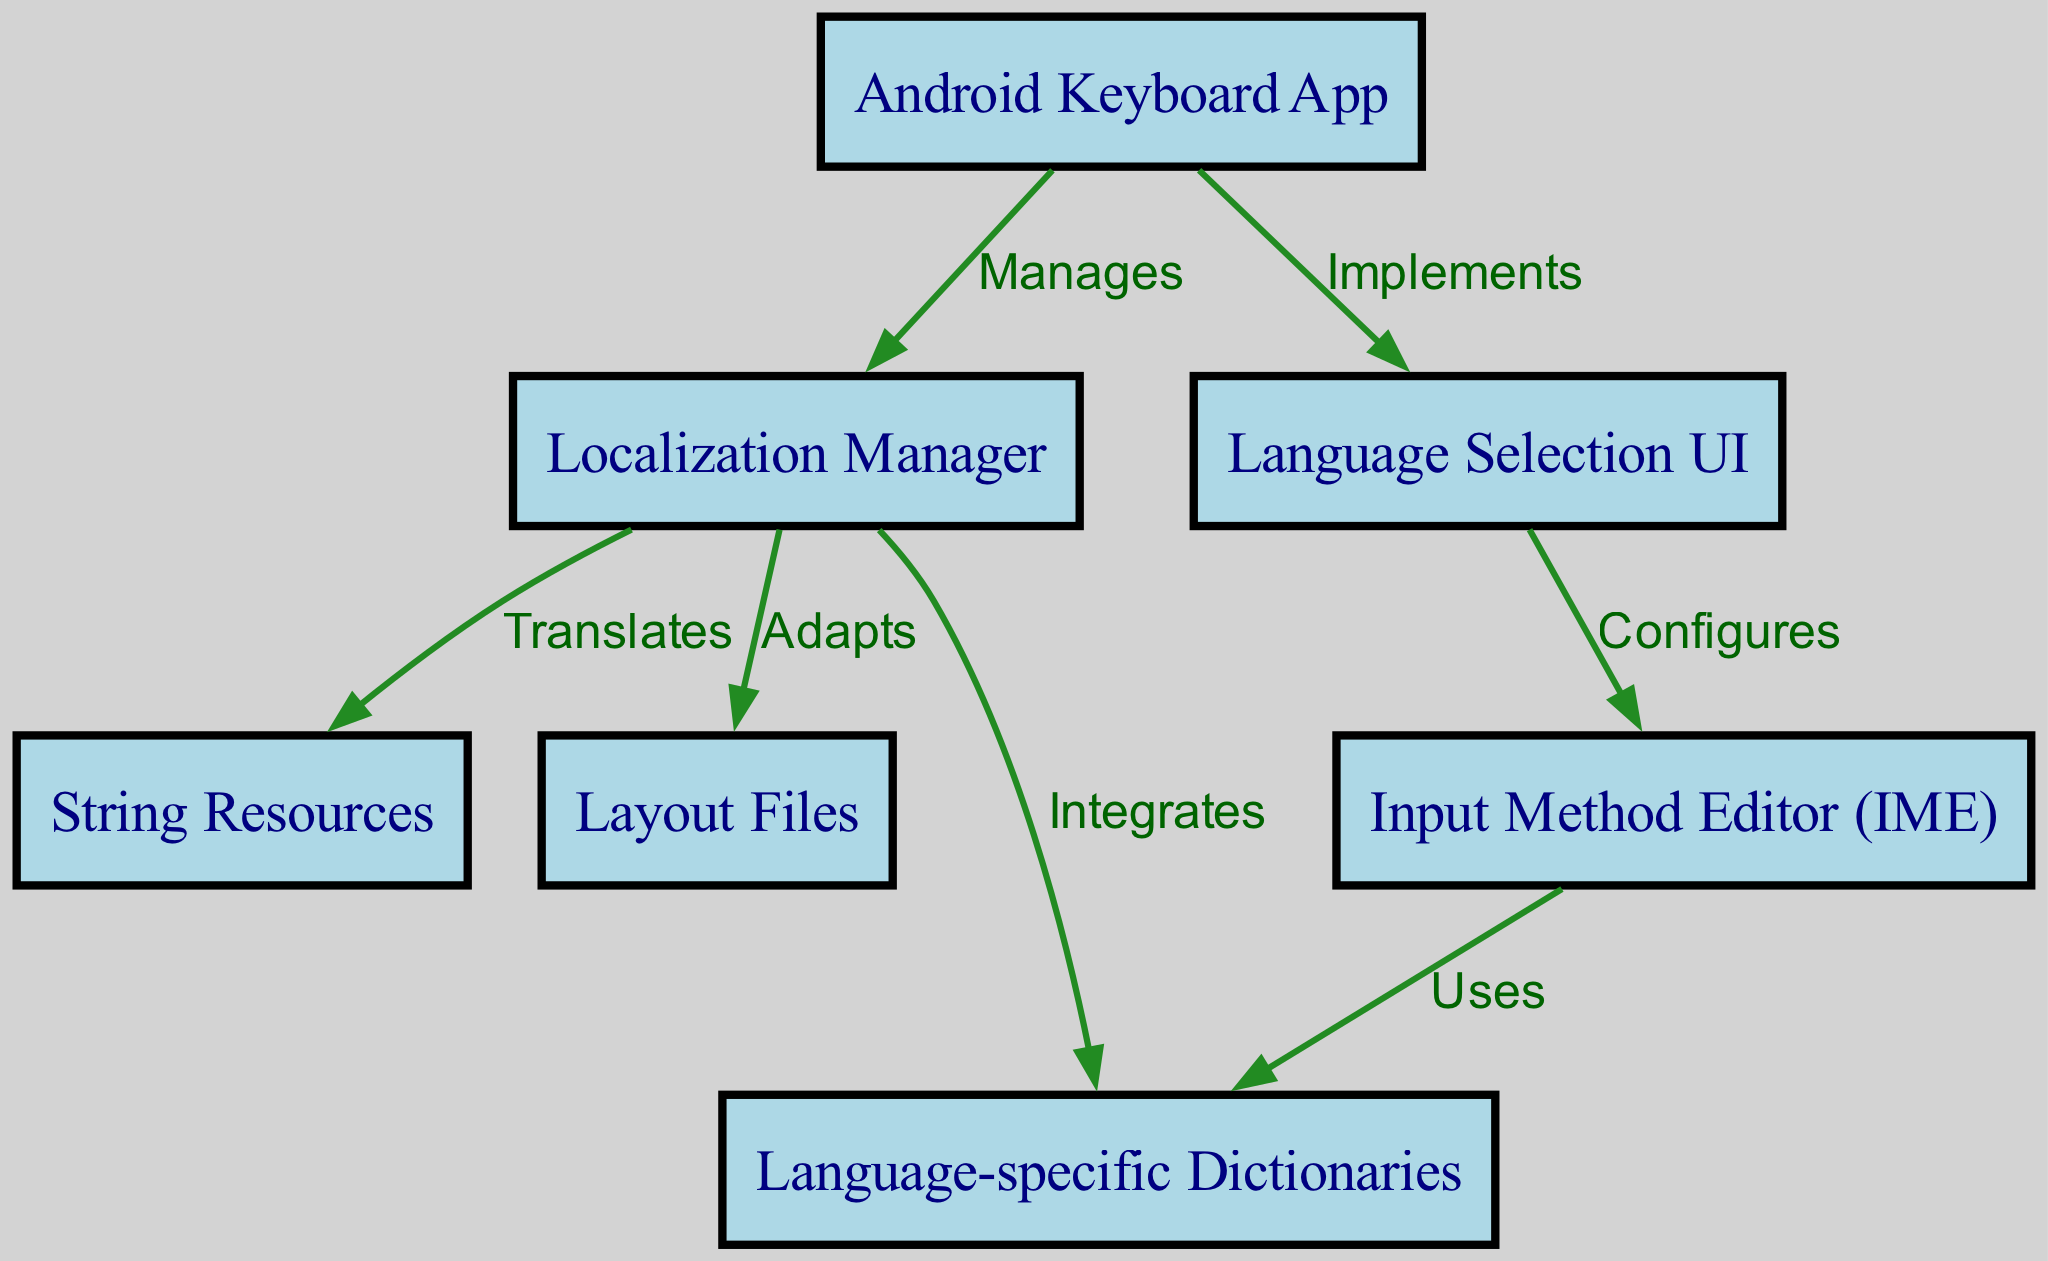What is the total number of nodes in the diagram? By counting the distinct nodes listed in the data, I found 7 nodes: Android Keyboard App, Localization Manager, String Resources, Layout Files, Language-specific Dictionaries, Input Method Editor (IME), and Language Selection UI.
Answer: 7 What is the relationship between the Android Keyboard App and the Localization Manager? The edge labeled "Manages" between these two nodes indicates that the Android Keyboard App oversees or controls the Localization Manager, establishing a hierarchical relationship.
Answer: Manages Which node is used by the Input Method Editor? The edge labeled "Uses" indicates that the Input Method Editor utilizes the Language-specific Dictionaries, establishing a direct link between these two nodes.
Answer: Language-specific Dictionaries How many edges are present in the diagram? I counted all the directed edges connecting the nodes. There are 6 edges in total, representing various relationships.
Answer: 6 What does the Localization Manager do with String Resources? The edge labeled "Translates" indicates that the Localization Manager performs functions that involve converting or adapting String Resources for different languages.
Answer: Translates What is the role of the Language Selection UI in the diagram? The edge labeled "Implements" connecting the Android Keyboard App to the Language Selection UI suggests that this UI is a component that is directly part of or executed by the Android Keyboard App, allowing users to choose their language.
Answer: Implements Which node integrates language-specific dictionaries? The edge labeled "Integrates" connects the Localization Manager and Language-specific Dictionaries, which shows that the Localization Manager incorporates these dictionaries into the overall keyboard system.
Answer: Language-specific Dictionaries What connects the Language Selection UI and the Input Method Editor? The edge labeled "Configures" shows that the Language Selection UI sets up or configures the Input Method Editor, establishing a clear link between UI selection and input processing.
Answer: Configures 